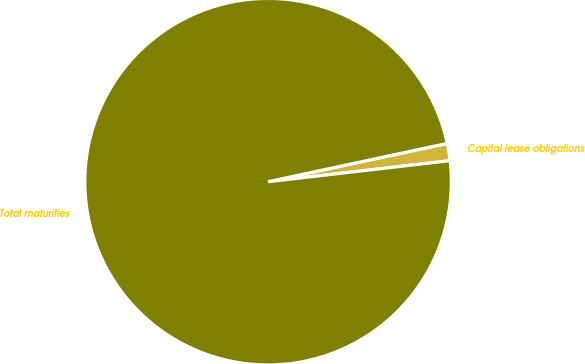<chart> <loc_0><loc_0><loc_500><loc_500><pie_chart><fcel>Capital lease obligations<fcel>Total maturities<nl><fcel>1.52%<fcel>98.48%<nl></chart> 